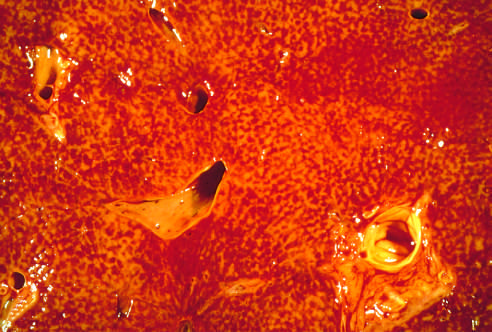re major blood vessels visible?
Answer the question using a single word or phrase. Yes 